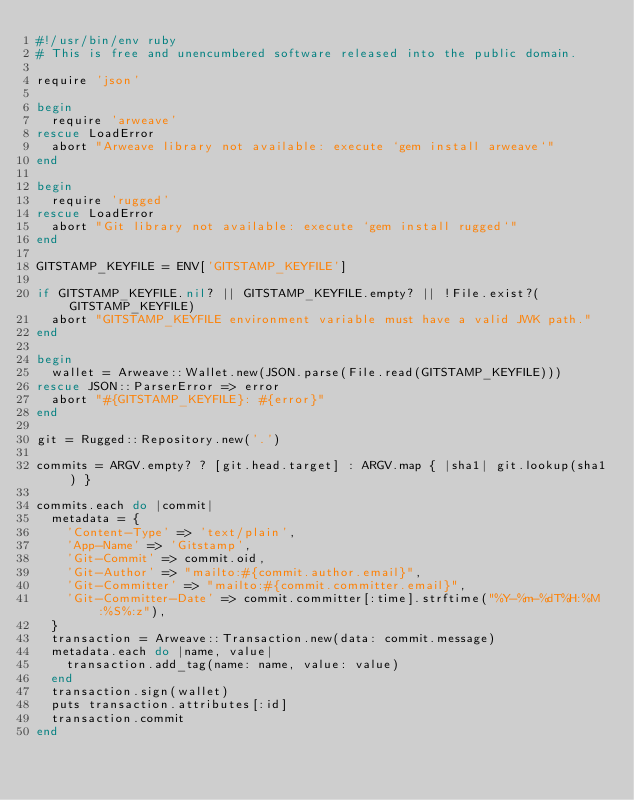<code> <loc_0><loc_0><loc_500><loc_500><_Ruby_>#!/usr/bin/env ruby
# This is free and unencumbered software released into the public domain.

require 'json'

begin
  require 'arweave'
rescue LoadError
  abort "Arweave library not available: execute `gem install arweave`"
end

begin
  require 'rugged'
rescue LoadError
  abort "Git library not available: execute `gem install rugged`"
end

GITSTAMP_KEYFILE = ENV['GITSTAMP_KEYFILE']

if GITSTAMP_KEYFILE.nil? || GITSTAMP_KEYFILE.empty? || !File.exist?(GITSTAMP_KEYFILE)
  abort "GITSTAMP_KEYFILE environment variable must have a valid JWK path."
end

begin
  wallet = Arweave::Wallet.new(JSON.parse(File.read(GITSTAMP_KEYFILE)))
rescue JSON::ParserError => error
  abort "#{GITSTAMP_KEYFILE}: #{error}"
end

git = Rugged::Repository.new('.')

commits = ARGV.empty? ? [git.head.target] : ARGV.map { |sha1| git.lookup(sha1) }

commits.each do |commit|
  metadata = {
    'Content-Type' => 'text/plain',
    'App-Name' => 'Gitstamp',
    'Git-Commit' => commit.oid,
    'Git-Author' => "mailto:#{commit.author.email}",
    'Git-Committer' => "mailto:#{commit.committer.email}",
    'Git-Committer-Date' => commit.committer[:time].strftime("%Y-%m-%dT%H:%M:%S%:z"),
  }
  transaction = Arweave::Transaction.new(data: commit.message)
  metadata.each do |name, value|
    transaction.add_tag(name: name, value: value)
  end
  transaction.sign(wallet)
  puts transaction.attributes[:id]
  transaction.commit
end
</code> 